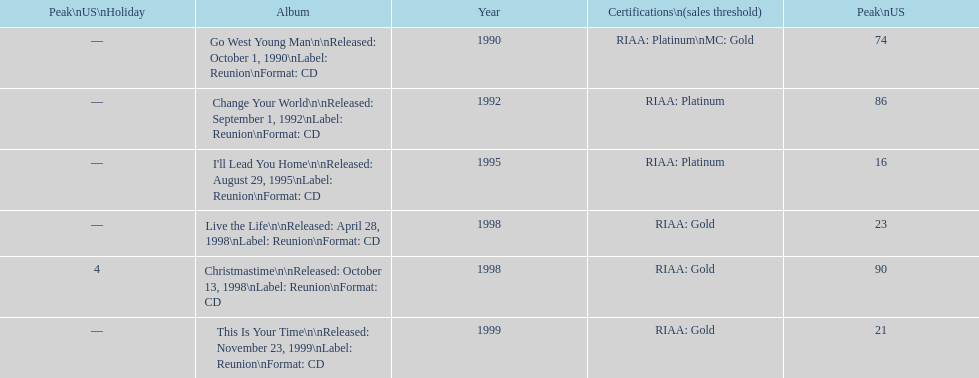How many songs are listed from 1998? 2. 